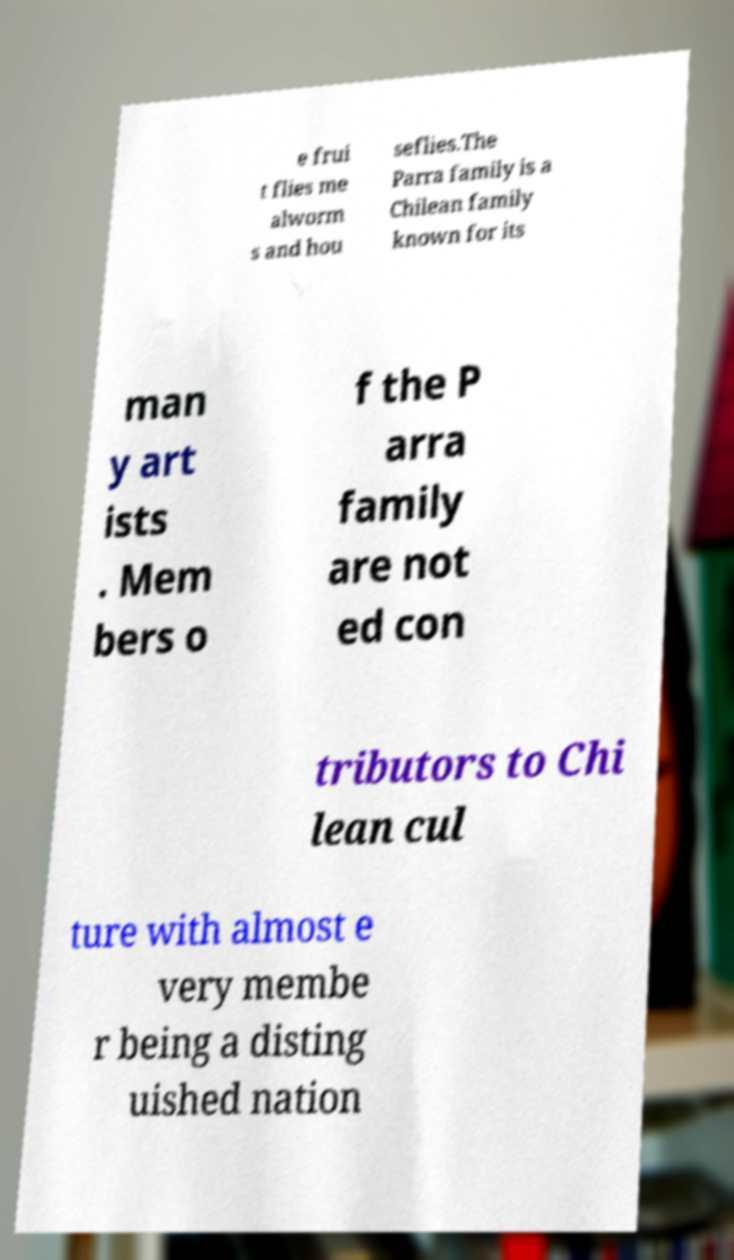Could you extract and type out the text from this image? e frui t flies me alworm s and hou seflies.The Parra family is a Chilean family known for its man y art ists . Mem bers o f the P arra family are not ed con tributors to Chi lean cul ture with almost e very membe r being a disting uished nation 